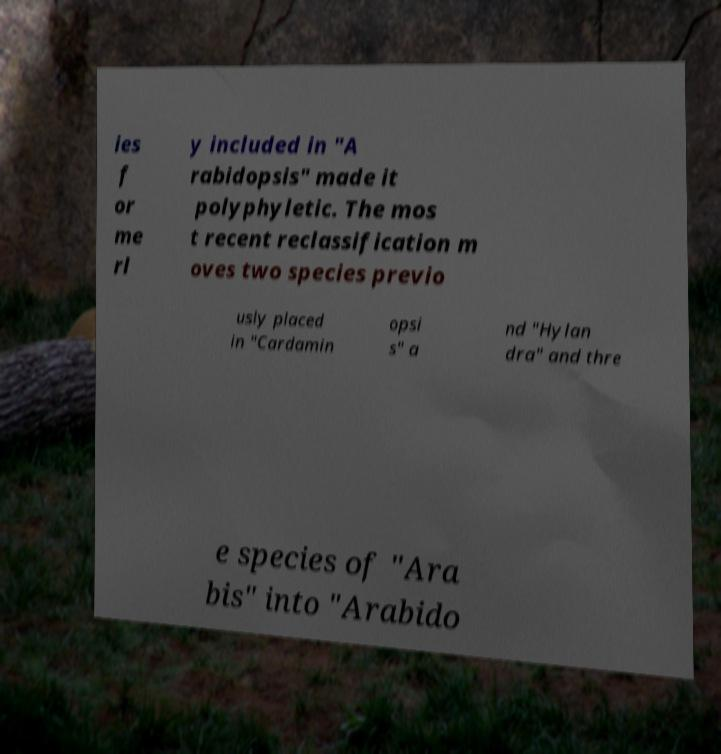Can you read and provide the text displayed in the image?This photo seems to have some interesting text. Can you extract and type it out for me? ies f or me rl y included in "A rabidopsis" made it polyphyletic. The mos t recent reclassification m oves two species previo usly placed in "Cardamin opsi s" a nd "Hylan dra" and thre e species of "Ara bis" into "Arabido 